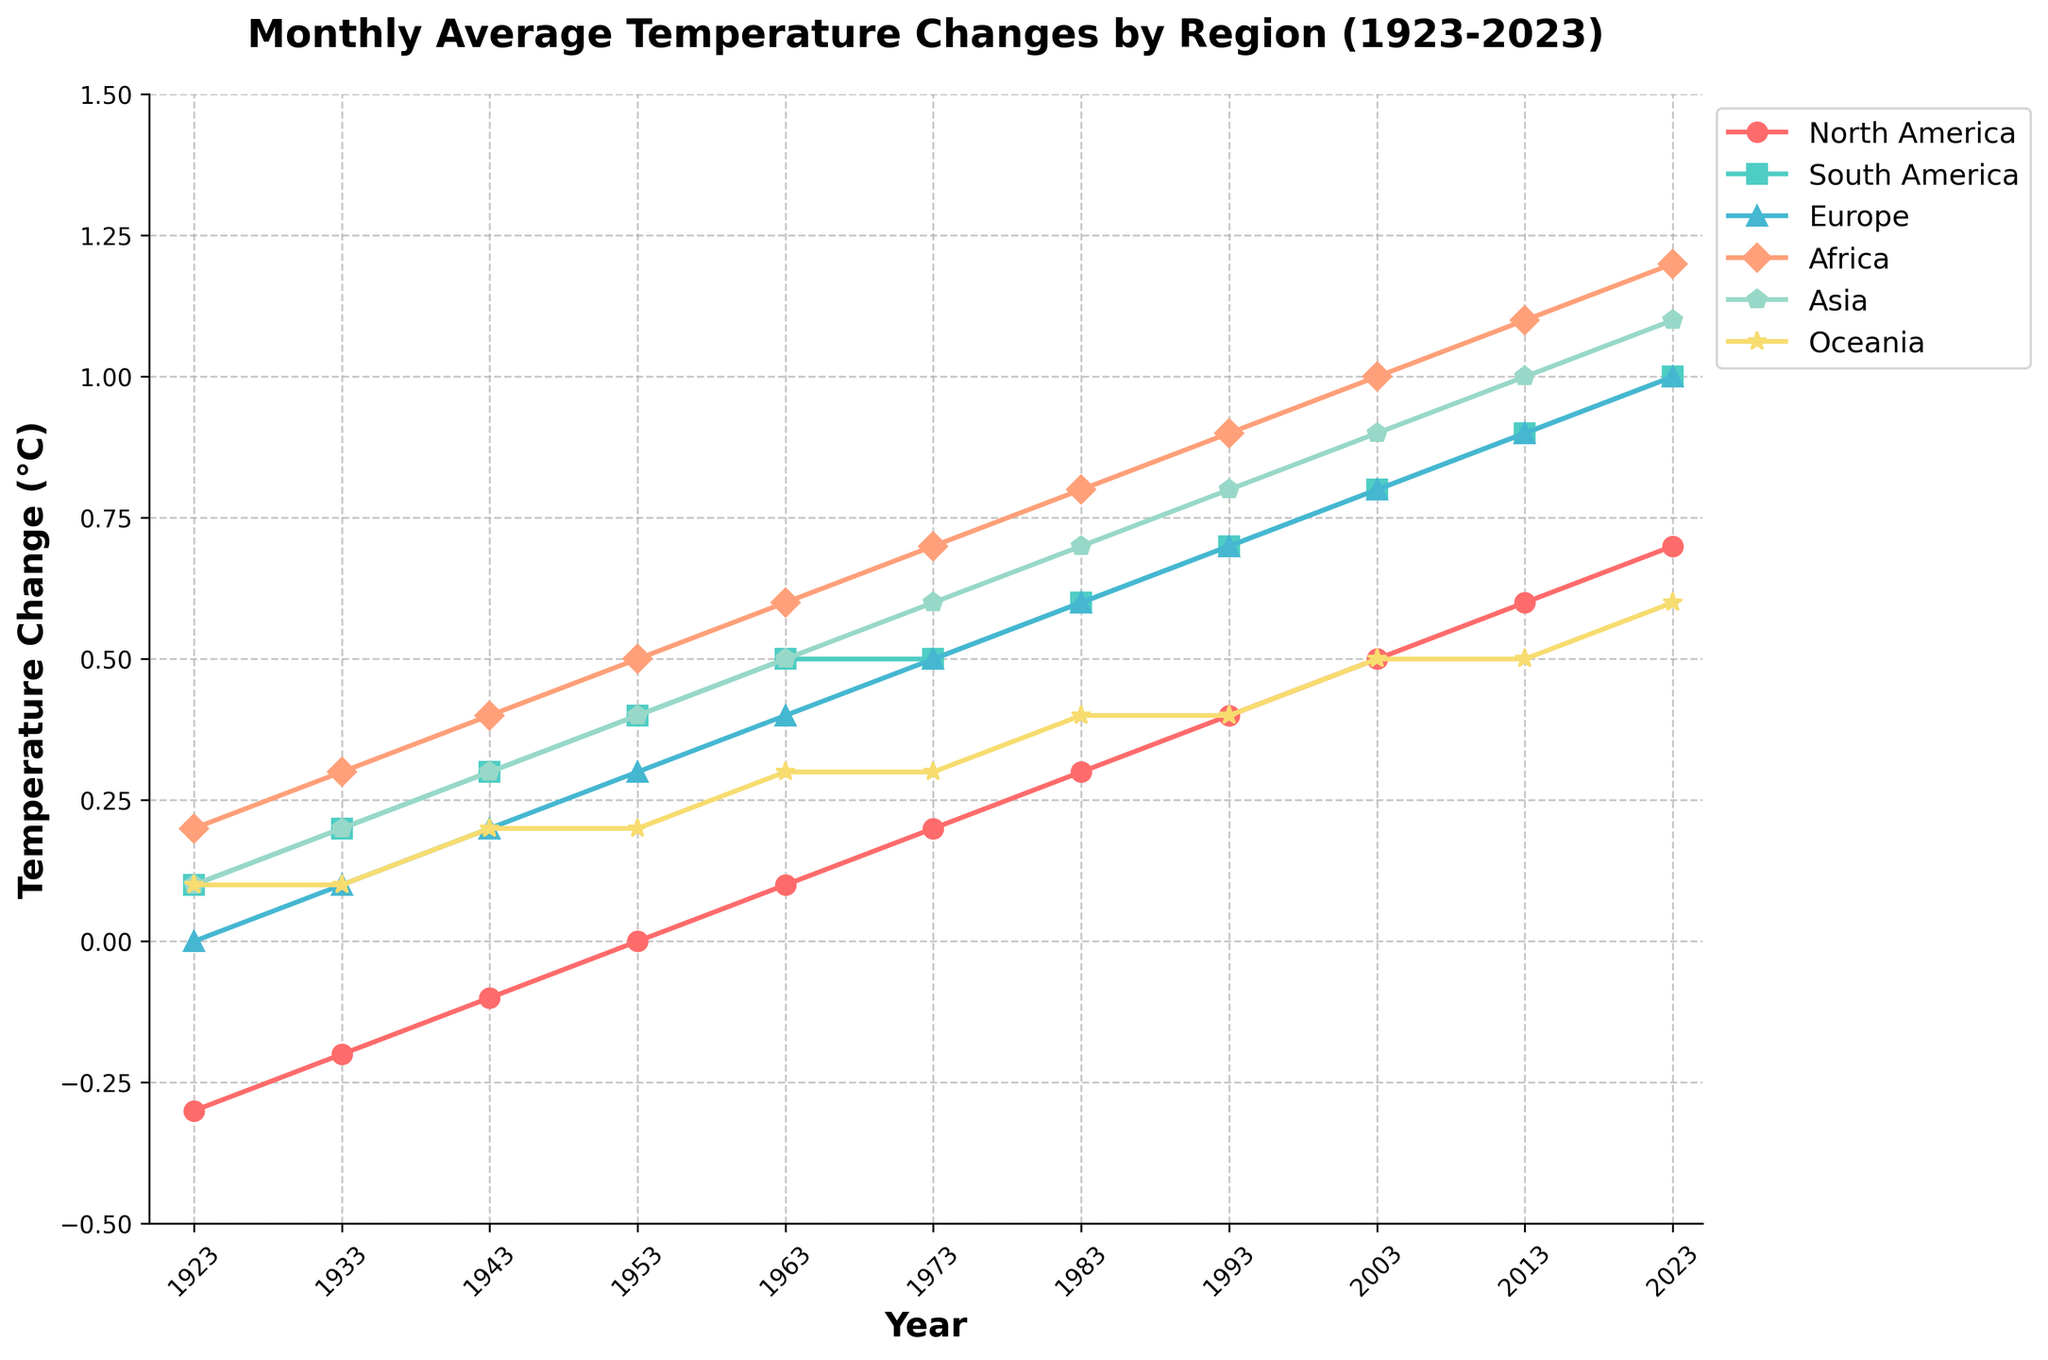What is the title of the plot? The title of the plot can be directly seen at the top of the figure. The title is "Monthly Average Temperature Changes by Region (1923-2023)".
Answer: Monthly Average Temperature Changes by Region (1923-2023) Which axis represents the years, and which axis represents the temperature change? The years are represented on the x-axis while the temperature change (°C) is represented on the y-axis, as indicated by the axis labels.
Answer: x-axis for years, y-axis for temperature change What is the general trend of temperature change in Asia from 1923 to 2023? By examining the plot, it's clear that the temperature change in Asia has steadily increased from 0.1°C in 1923 to 1.1°C in 2023.
Answer: Increasing trend Which region experienced the highest temperature change in 2023, and what was the value? To find the highest temperature change in 2023, compare all regions' data points for that year. Africa shows the highest temperature change at 1.2°C.
Answer: Africa, 1.2°C How many data points are plotted for each region? Each region has temperature change data from 1923 up to 2023, recorded every 10 years. Counting the number of data points along the x-axis for any region confirms that there are 11 data points per region.
Answer: 11 data points What are the temperature changes for North America in 1953 and 1973, and what is the difference between these two values? Looking at the data points for North America in 1953 and 1973, the temperature changes are 0.0°C and 0.2°C respectively. The difference is 0.2°C - 0.0°C = 0.2°C.
Answer: 0.2°C Which region had the smallest change in temperature in the year 1933? Look at the temperature change data for 1933 across all regions. North America and Oceania both have the smallest change at 0.1°C.
Answer: North America and Oceania, 0.1°C Did Oceania's temperature change ever exceed 0.5°C within the observed time period? Checking the plot, the highest temperature change for Oceania is in 2023 with a value of 0.6°C, indicating that it indeed exceeded 0.5°C.
Answer: Yes Which regions' temperature changes were equal in 1983? Check the plotted lines for the year 1983. Europe and South America both have a temperature change of 0.6°C in 1983.
Answer: Europe and South America By how many degrees did the temperature change in Europe increase between 1943 and 2023? The temperature changes in Europe for 1943 and 2023 are 0.2°C and 1.0°C respectively. The increase is calculated as 1.0°C - 0.2°C = 0.8°C.
Answer: 0.8°C 